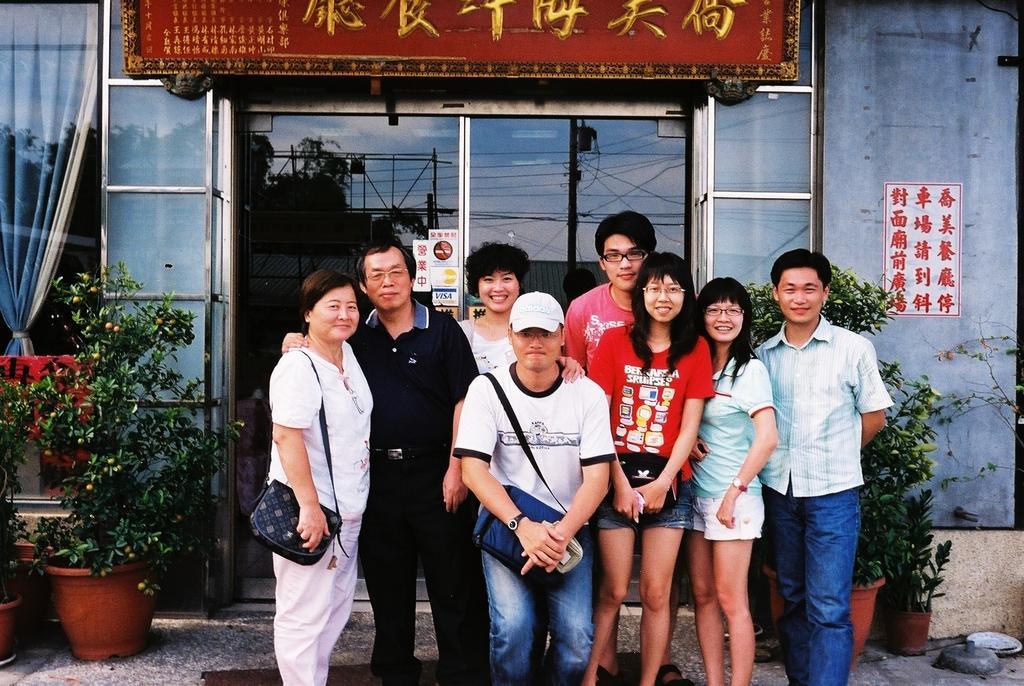Can you describe this image briefly? In this picture I can see there are a group of people standing here and among them four of them are women and remaining four are men. The men are wearing shirts and pant, women are wearing shirts and trouser. In the backdrop I can see there is a door, a window and a plant. There is a red color name board. 